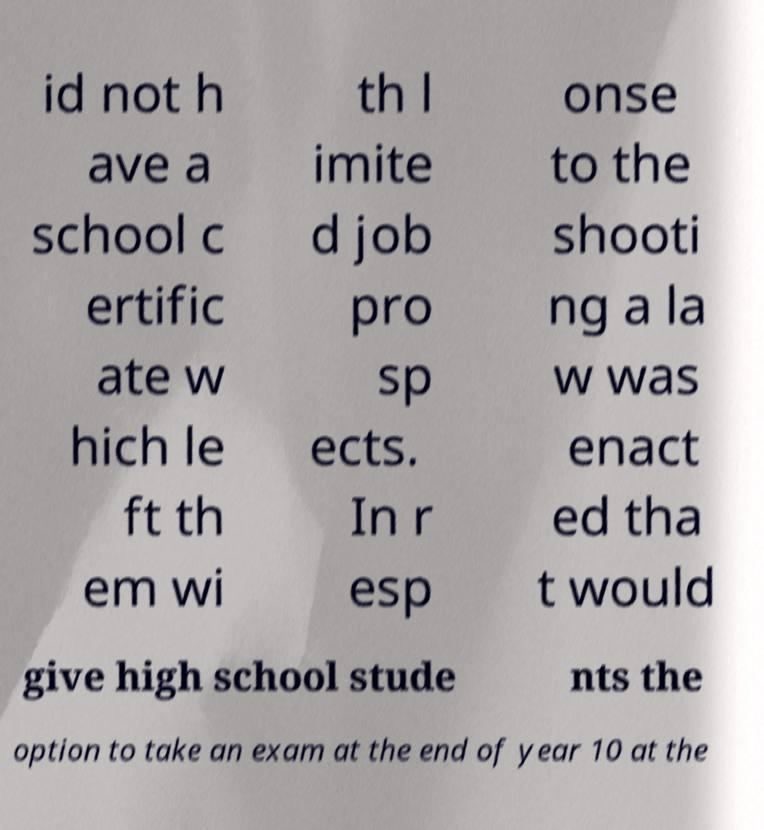For documentation purposes, I need the text within this image transcribed. Could you provide that? id not h ave a school c ertific ate w hich le ft th em wi th l imite d job pro sp ects. In r esp onse to the shooti ng a la w was enact ed tha t would give high school stude nts the option to take an exam at the end of year 10 at the 